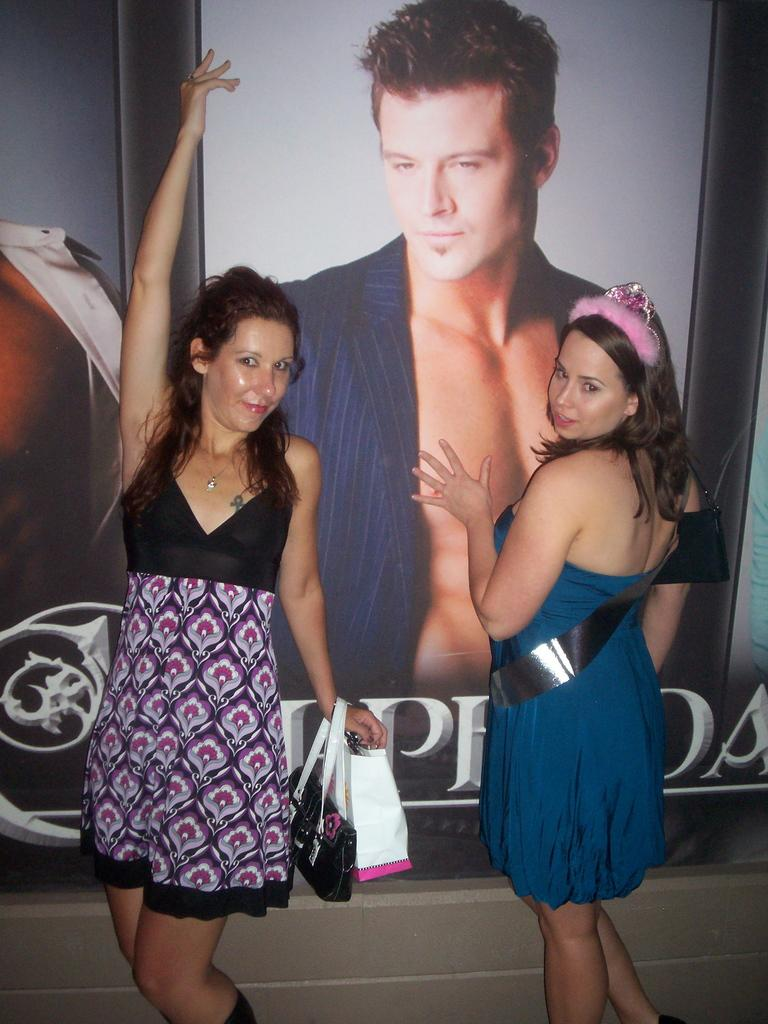How many people are in the image? There are two women standing in the image. What are the women wearing? The women are wearing clothes. What are the women holding in their hands? The women are holding handbags. What can be seen on the poster in the image? There is a poster of a man in the image. What type of wire is being used by the frog in the image? There is no frog or wire present in the image. What is the frog carrying on the tray in the image? There is no frog or tray present in the image. 